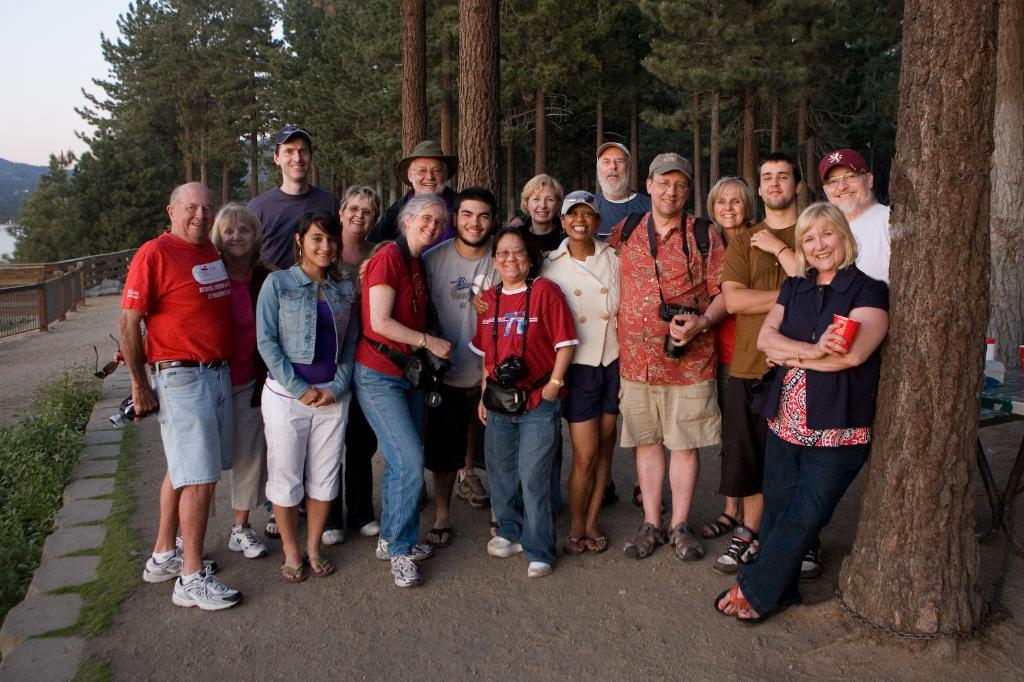How many people are in the image? There is a group of people in the image. What are the people in the image doing? The people are standing and smiling. What can be seen behind the group of people? There are trees behind the group of people. What is visible on the left side of the image? The sky is visible on the left side of the image. What rule is being enforced by the group of people in the image? There is no indication of any rule being enforced in the image; the people are simply standing and smiling. 